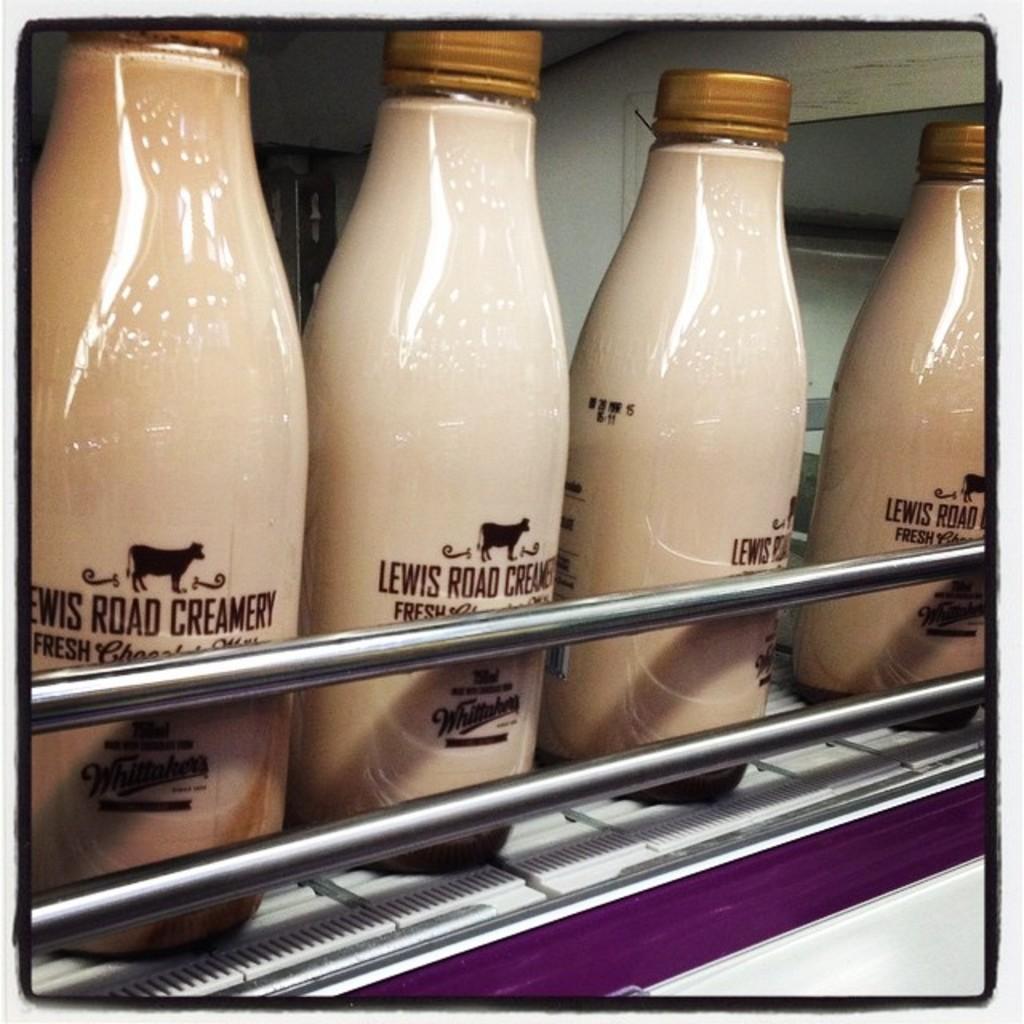Describe this image in one or two sentences. In this picture we can see bottles with some text on it and metal rods in the foreground. 